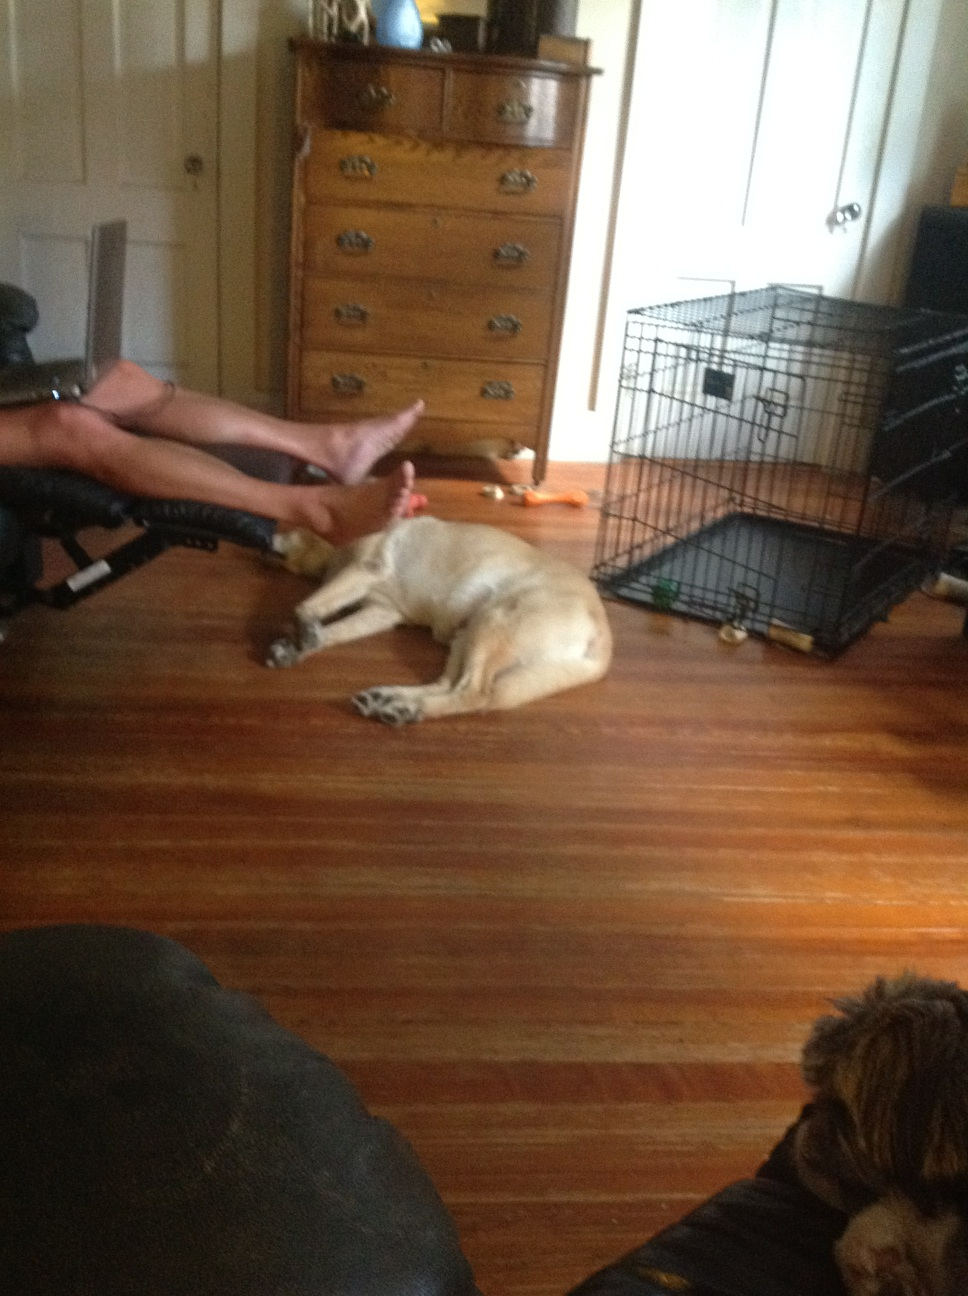Can you describe the room's furniture? Certainly! The room includes a wooden chest of drawers with decorative metal handles, appearing to be of a traditional style. There's also a metal pet crate with a tray inside, suggesting this is an area for pets. A part of a black chair, possibly made of leather, is noticeable in the forefront, indicating comfortable seating available in the room. 